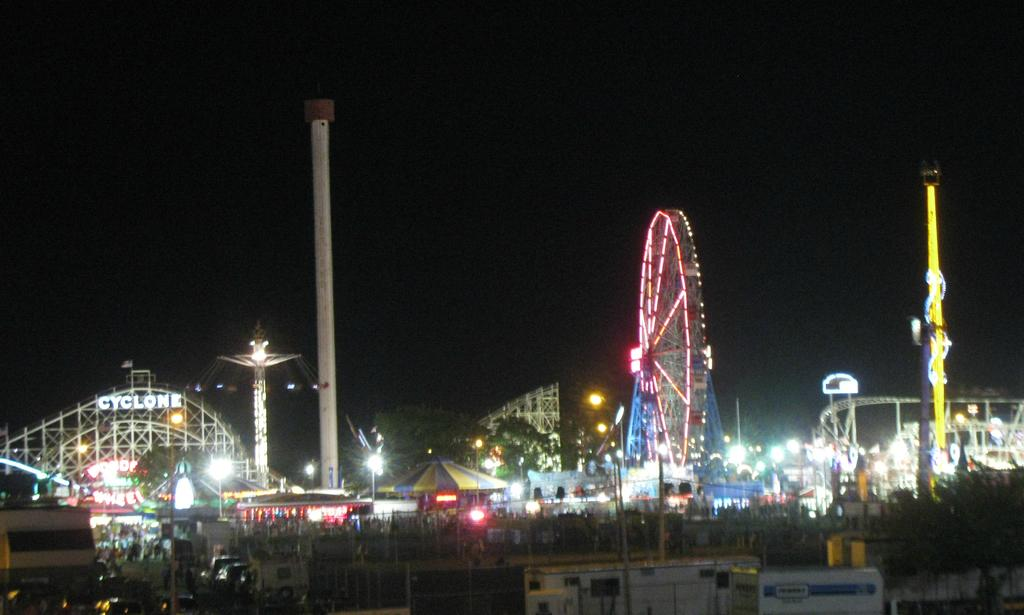What type of location is shown in the aerial view of the image? The image is an aerial view of a carnival. What is the main attraction in the middle of the carnival? There is a giant wheel in the middle of the carnival. What type of ride can be seen on the right side of the carnival? There is a roller coaster on the right side of the carnival. What kind of establishments are present in the carnival? There are many stores in the carnival. What are the people in the carnival doing? People are walking on the land in the carnival. What nerve is responsible for the sensation of fear in the image? There is no mention of fear or any specific nerve in the image; it is an aerial view of a carnival with various attractions and people walking around. 